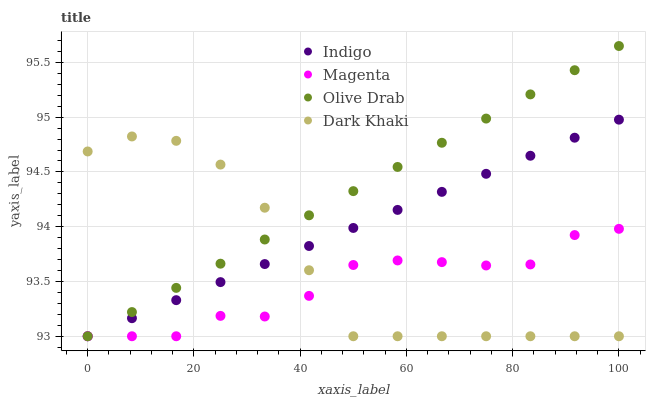Does Magenta have the minimum area under the curve?
Answer yes or no. Yes. Does Olive Drab have the maximum area under the curve?
Answer yes or no. Yes. Does Indigo have the minimum area under the curve?
Answer yes or no. No. Does Indigo have the maximum area under the curve?
Answer yes or no. No. Is Indigo the smoothest?
Answer yes or no. Yes. Is Magenta the roughest?
Answer yes or no. Yes. Is Magenta the smoothest?
Answer yes or no. No. Is Indigo the roughest?
Answer yes or no. No. Does Dark Khaki have the lowest value?
Answer yes or no. Yes. Does Olive Drab have the highest value?
Answer yes or no. Yes. Does Indigo have the highest value?
Answer yes or no. No. Does Magenta intersect Olive Drab?
Answer yes or no. Yes. Is Magenta less than Olive Drab?
Answer yes or no. No. Is Magenta greater than Olive Drab?
Answer yes or no. No. 